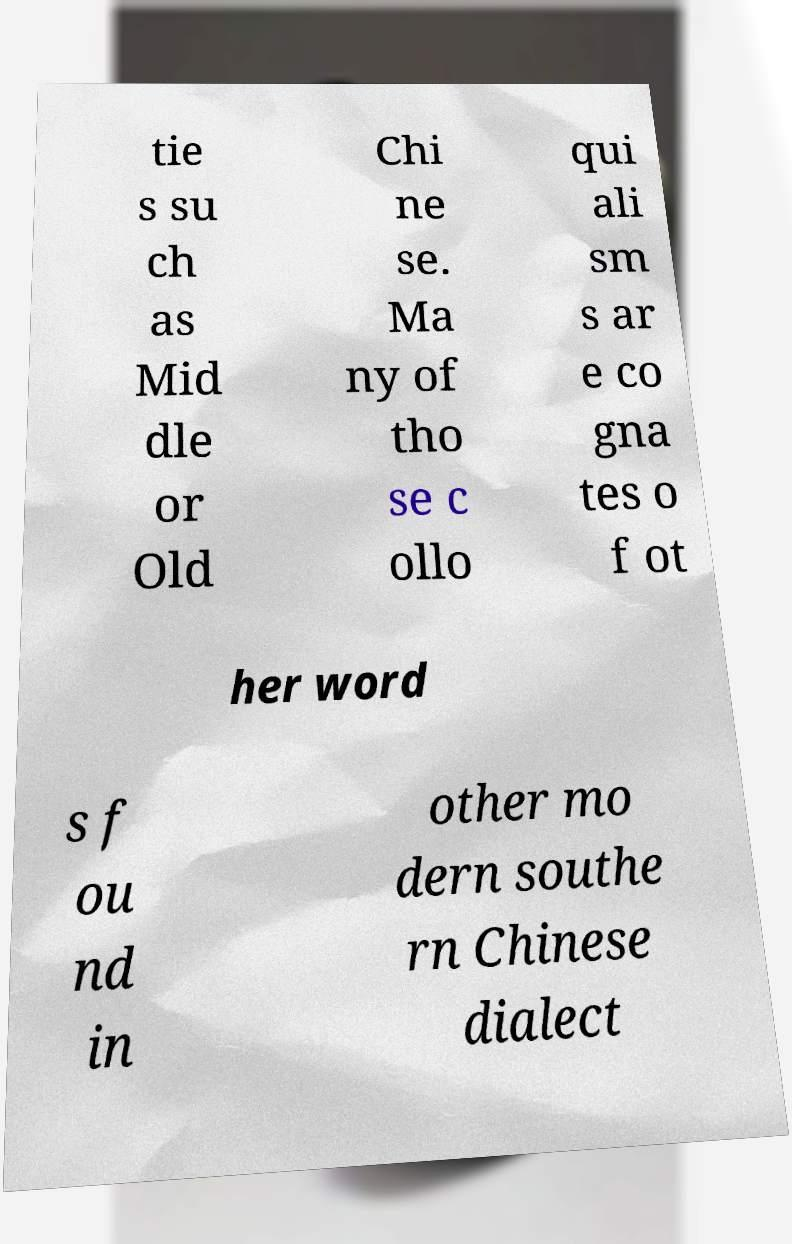For documentation purposes, I need the text within this image transcribed. Could you provide that? tie s su ch as Mid dle or Old Chi ne se. Ma ny of tho se c ollo qui ali sm s ar e co gna tes o f ot her word s f ou nd in other mo dern southe rn Chinese dialect 